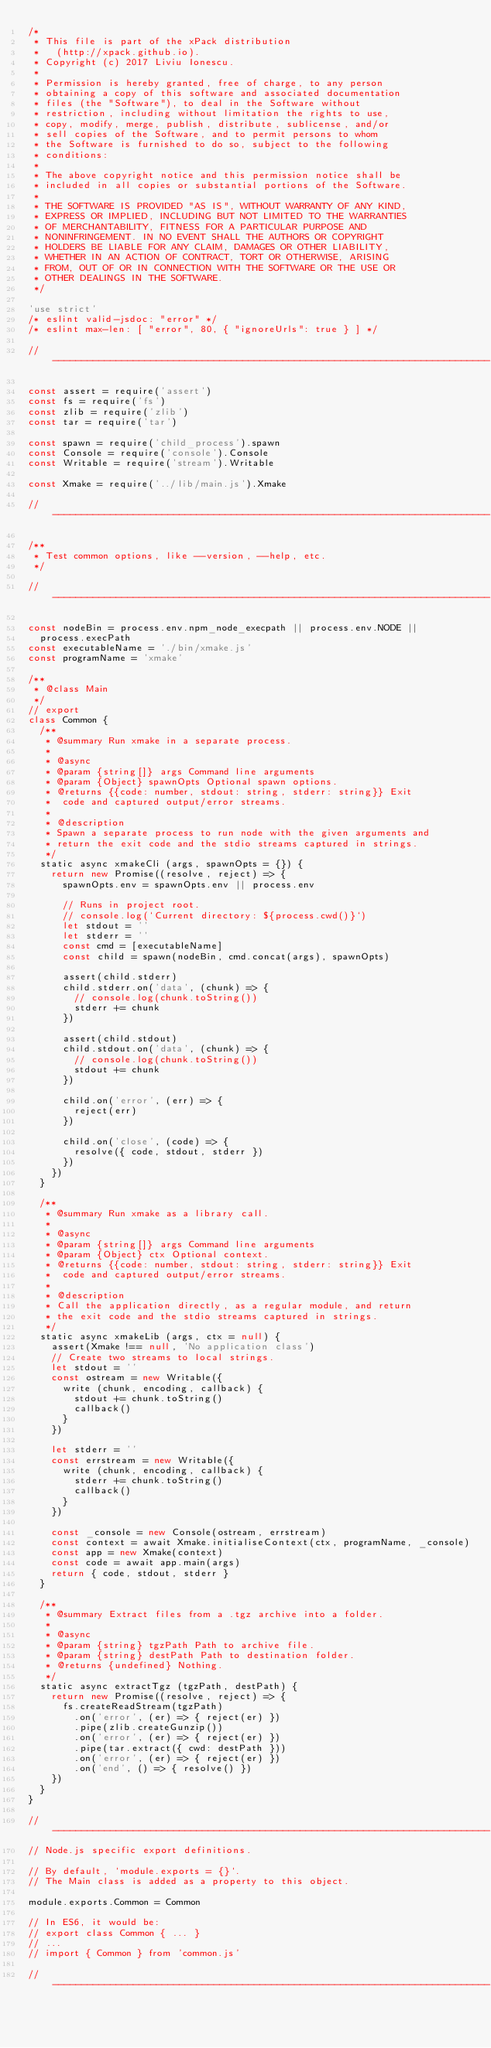<code> <loc_0><loc_0><loc_500><loc_500><_JavaScript_>/*
 * This file is part of the xPack distribution
 *   (http://xpack.github.io).
 * Copyright (c) 2017 Liviu Ionescu.
 *
 * Permission is hereby granted, free of charge, to any person
 * obtaining a copy of this software and associated documentation
 * files (the "Software"), to deal in the Software without
 * restriction, including without limitation the rights to use,
 * copy, modify, merge, publish, distribute, sublicense, and/or
 * sell copies of the Software, and to permit persons to whom
 * the Software is furnished to do so, subject to the following
 * conditions:
 *
 * The above copyright notice and this permission notice shall be
 * included in all copies or substantial portions of the Software.
 *
 * THE SOFTWARE IS PROVIDED "AS IS", WITHOUT WARRANTY OF ANY KIND,
 * EXPRESS OR IMPLIED, INCLUDING BUT NOT LIMITED TO THE WARRANTIES
 * OF MERCHANTABILITY, FITNESS FOR A PARTICULAR PURPOSE AND
 * NONINFRINGEMENT. IN NO EVENT SHALL THE AUTHORS OR COPYRIGHT
 * HOLDERS BE LIABLE FOR ANY CLAIM, DAMAGES OR OTHER LIABILITY,
 * WHETHER IN AN ACTION OF CONTRACT, TORT OR OTHERWISE, ARISING
 * FROM, OUT OF OR IN CONNECTION WITH THE SOFTWARE OR THE USE OR
 * OTHER DEALINGS IN THE SOFTWARE.
 */

'use strict'
/* eslint valid-jsdoc: "error" */
/* eslint max-len: [ "error", 80, { "ignoreUrls": true } ] */

// ----------------------------------------------------------------------------

const assert = require('assert')
const fs = require('fs')
const zlib = require('zlib')
const tar = require('tar')

const spawn = require('child_process').spawn
const Console = require('console').Console
const Writable = require('stream').Writable

const Xmake = require('../lib/main.js').Xmake

// ----------------------------------------------------------------------------

/**
 * Test common options, like --version, --help, etc.
 */

// ----------------------------------------------------------------------------

const nodeBin = process.env.npm_node_execpath || process.env.NODE ||
  process.execPath
const executableName = './bin/xmake.js'
const programName = 'xmake'

/**
 * @class Main
 */
// export
class Common {
  /**
   * @summary Run xmake in a separate process.
   *
   * @async
   * @param {string[]} args Command line arguments
   * @param {Object} spawnOpts Optional spawn options.
   * @returns {{code: number, stdout: string, stderr: string}} Exit
   *  code and captured output/error streams.
   *
   * @description
   * Spawn a separate process to run node with the given arguments and
   * return the exit code and the stdio streams captured in strings.
   */
  static async xmakeCli (args, spawnOpts = {}) {
    return new Promise((resolve, reject) => {
      spawnOpts.env = spawnOpts.env || process.env

      // Runs in project root.
      // console.log(`Current directory: ${process.cwd()}`)
      let stdout = ''
      let stderr = ''
      const cmd = [executableName]
      const child = spawn(nodeBin, cmd.concat(args), spawnOpts)

      assert(child.stderr)
      child.stderr.on('data', (chunk) => {
        // console.log(chunk.toString())
        stderr += chunk
      })

      assert(child.stdout)
      child.stdout.on('data', (chunk) => {
        // console.log(chunk.toString())
        stdout += chunk
      })

      child.on('error', (err) => {
        reject(err)
      })

      child.on('close', (code) => {
        resolve({ code, stdout, stderr })
      })
    })
  }

  /**
   * @summary Run xmake as a library call.
   *
   * @async
   * @param {string[]} args Command line arguments
   * @param {Object} ctx Optional context.
   * @returns {{code: number, stdout: string, stderr: string}} Exit
   *  code and captured output/error streams.
   *
   * @description
   * Call the application directly, as a regular module, and return
   * the exit code and the stdio streams captured in strings.
   */
  static async xmakeLib (args, ctx = null) {
    assert(Xmake !== null, 'No application class')
    // Create two streams to local strings.
    let stdout = ''
    const ostream = new Writable({
      write (chunk, encoding, callback) {
        stdout += chunk.toString()
        callback()
      }
    })

    let stderr = ''
    const errstream = new Writable({
      write (chunk, encoding, callback) {
        stderr += chunk.toString()
        callback()
      }
    })

    const _console = new Console(ostream, errstream)
    const context = await Xmake.initialiseContext(ctx, programName, _console)
    const app = new Xmake(context)
    const code = await app.main(args)
    return { code, stdout, stderr }
  }

  /**
   * @summary Extract files from a .tgz archive into a folder.
   *
   * @async
   * @param {string} tgzPath Path to archive file.
   * @param {string} destPath Path to destination folder.
   * @returns {undefined} Nothing.
   */
  static async extractTgz (tgzPath, destPath) {
    return new Promise((resolve, reject) => {
      fs.createReadStream(tgzPath)
        .on('error', (er) => { reject(er) })
        .pipe(zlib.createGunzip())
        .on('error', (er) => { reject(er) })
        .pipe(tar.extract({ cwd: destPath }))
        .on('error', (er) => { reject(er) })
        .on('end', () => { resolve() })
    })
  }
}

// ----------------------------------------------------------------------------
// Node.js specific export definitions.

// By default, `module.exports = {}`.
// The Main class is added as a property to this object.

module.exports.Common = Common

// In ES6, it would be:
// export class Common { ... }
// ...
// import { Common } from 'common.js'

// ----------------------------------------------------------------------------
</code> 